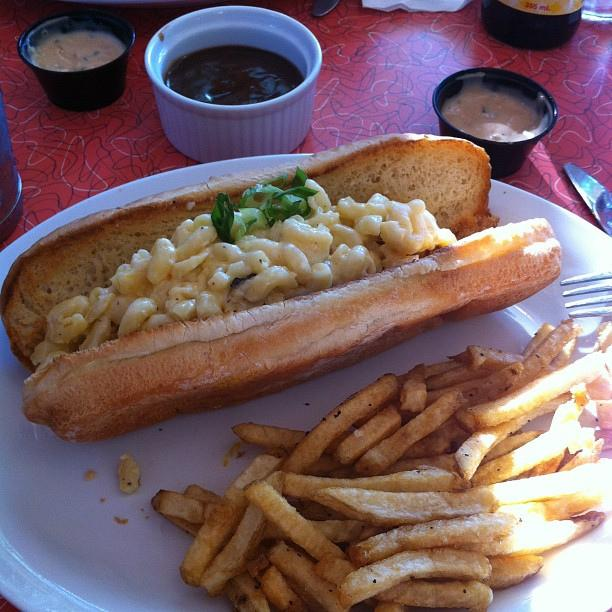What would usually be where the pasta is?

Choices:
A) eggs
B) hamburger
C) meatloaf
D) hot dog hot dog 